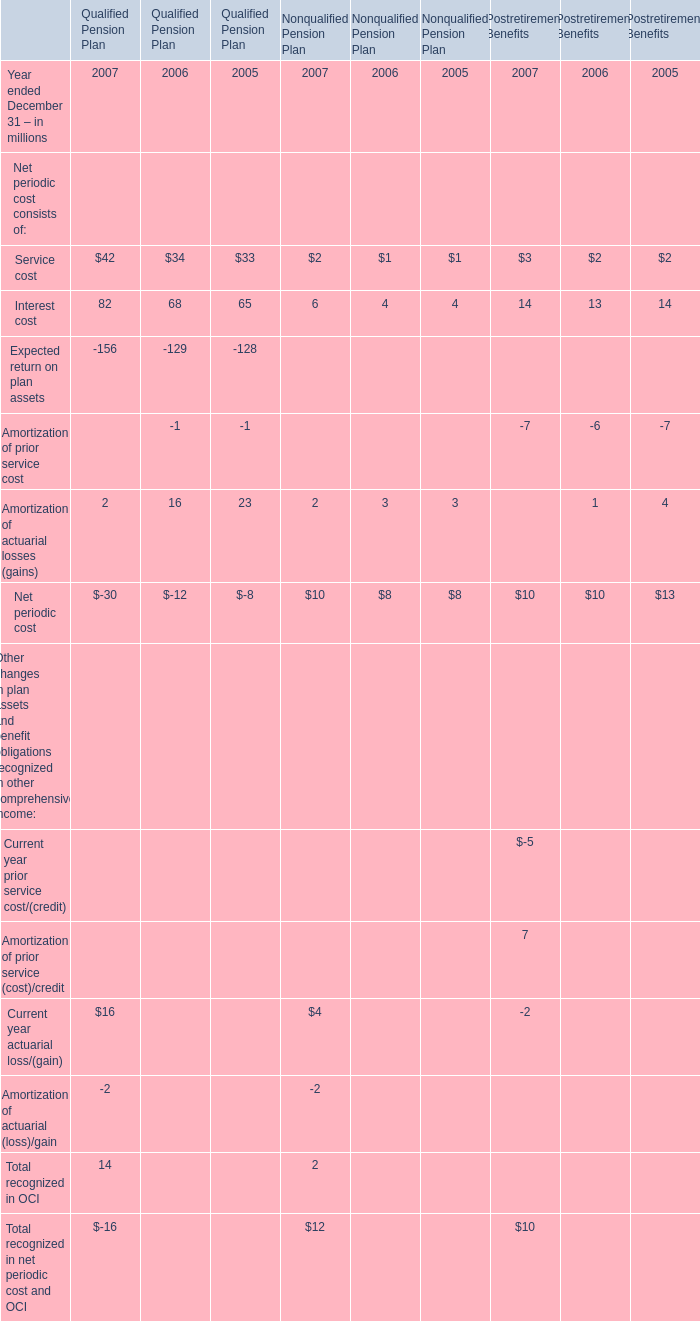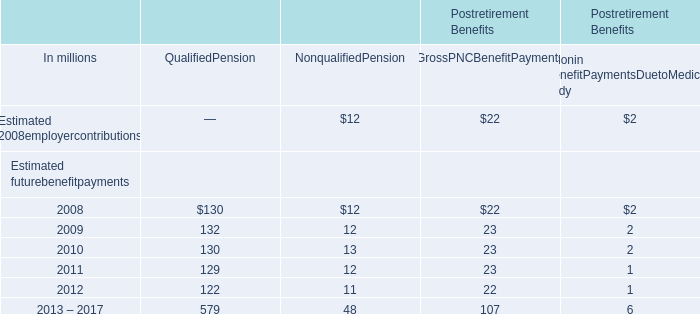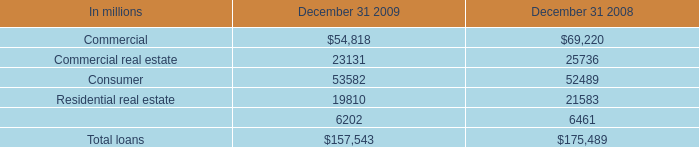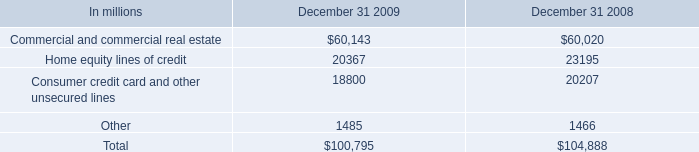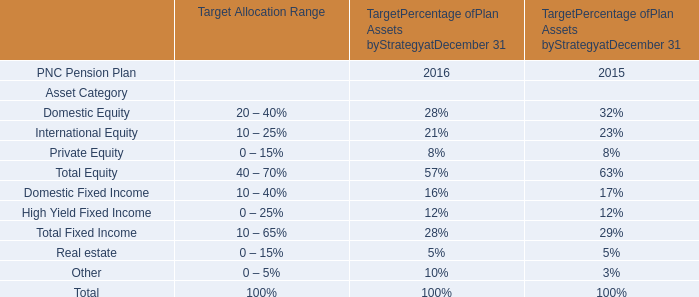What is the ratio of Amortization of actuarial losses (gains) to the total for Nonqualified Pension Plan in 2007? 
Computations: (2 / 12)
Answer: 0.16667. 